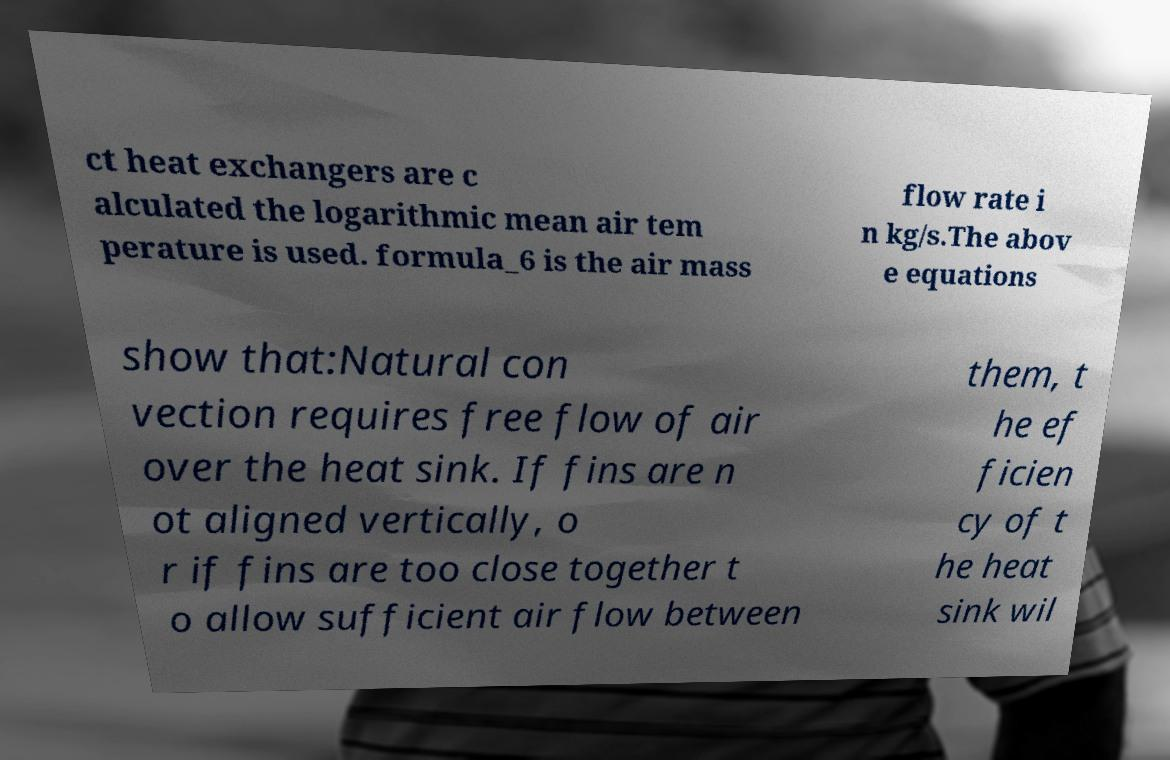For documentation purposes, I need the text within this image transcribed. Could you provide that? ct heat exchangers are c alculated the logarithmic mean air tem perature is used. formula_6 is the air mass flow rate i n kg/s.The abov e equations show that:Natural con vection requires free flow of air over the heat sink. If fins are n ot aligned vertically, o r if fins are too close together t o allow sufficient air flow between them, t he ef ficien cy of t he heat sink wil 